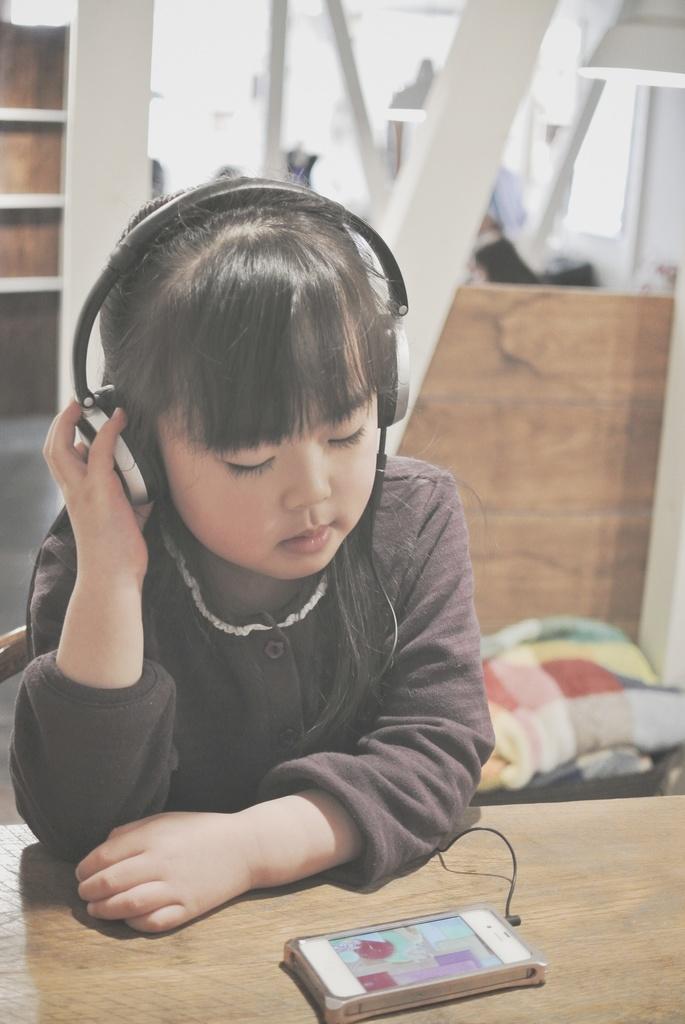Could you give a brief overview of what you see in this image? In this image there is a girl wearing headphones. Before her there is a table having a mobile. Right side there are clothes on the floor. Few lights are attached to the roof. Left side there is a rack. Background there is a wall. 